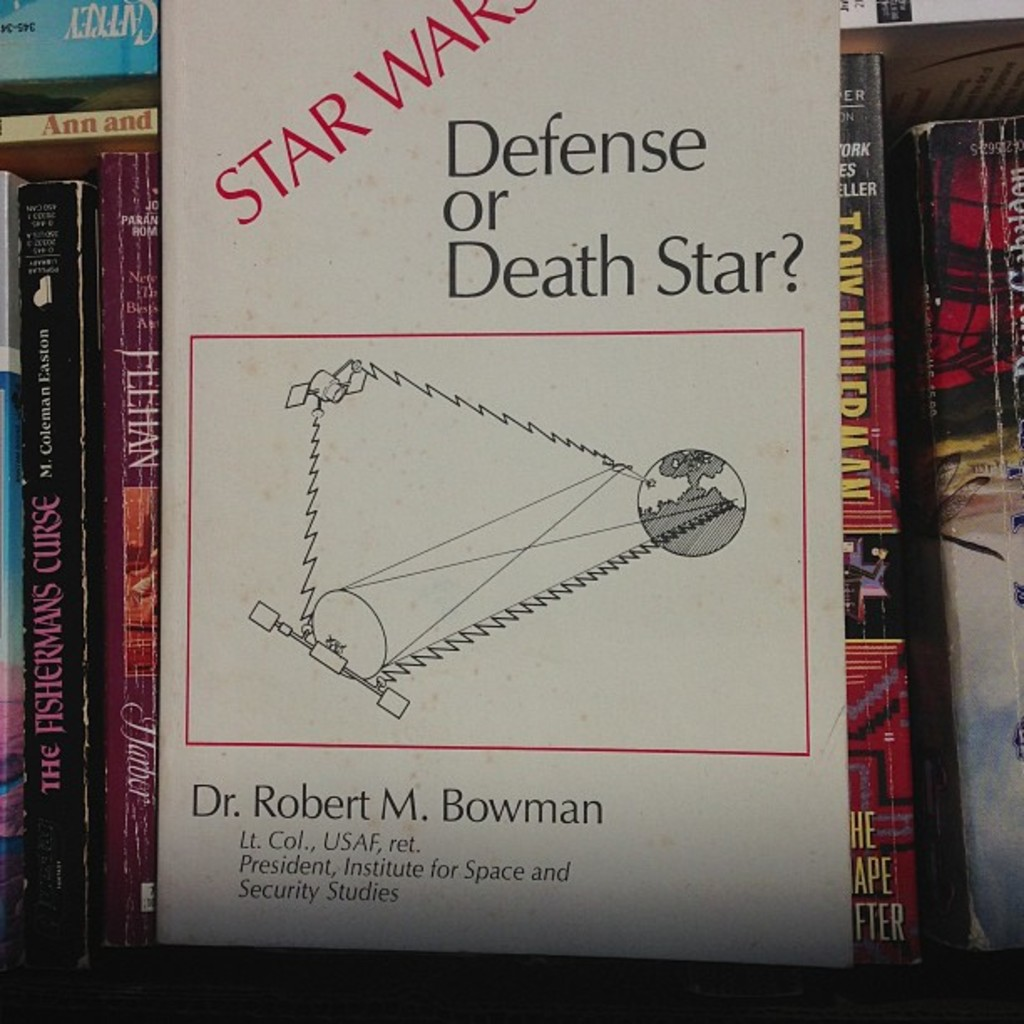Can you describe the main features of this image for me? The image features the cover of a book titled "Star Wars: Defense or Death Star?" by Dr. Robert M. Bowman, who is a retired Lieutenant Colonel from the United States Air Force and the President of the Institute for Space and Security Studies. The cover art is a black and white illustration of the Death Star, a fictional space station and superweapon featured in the Star Wars franchise, with a line connecting it to a planet. The book is placed on a shelf among other books. The cover suggests that the book might delve into the strategic and security implications of space warfare, possibly drawing parallels between real-world defense strategies and the fictional universe of Star Wars. 